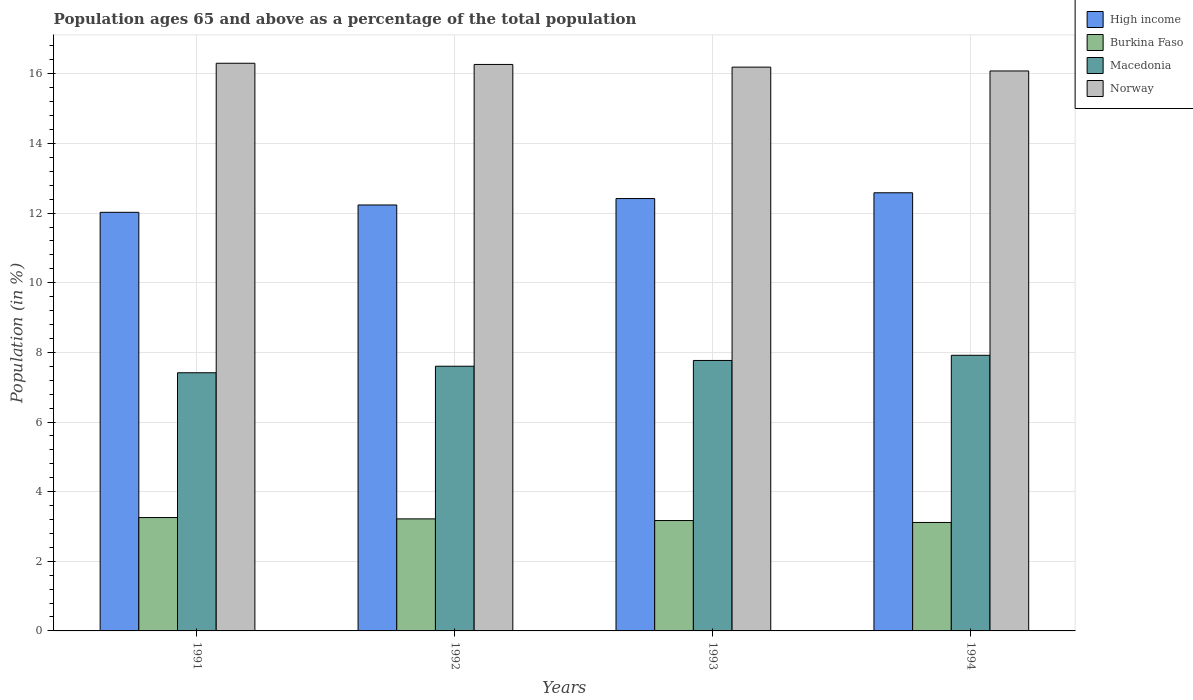How many different coloured bars are there?
Make the answer very short. 4. How many groups of bars are there?
Your answer should be compact. 4. Are the number of bars on each tick of the X-axis equal?
Make the answer very short. Yes. How many bars are there on the 4th tick from the right?
Offer a very short reply. 4. What is the label of the 4th group of bars from the left?
Keep it short and to the point. 1994. In how many cases, is the number of bars for a given year not equal to the number of legend labels?
Give a very brief answer. 0. What is the percentage of the population ages 65 and above in Burkina Faso in 1992?
Your answer should be compact. 3.22. Across all years, what is the maximum percentage of the population ages 65 and above in Burkina Faso?
Provide a succinct answer. 3.26. Across all years, what is the minimum percentage of the population ages 65 and above in Burkina Faso?
Provide a succinct answer. 3.11. In which year was the percentage of the population ages 65 and above in High income minimum?
Ensure brevity in your answer.  1991. What is the total percentage of the population ages 65 and above in Burkina Faso in the graph?
Your answer should be compact. 12.76. What is the difference between the percentage of the population ages 65 and above in Norway in 1992 and that in 1994?
Your answer should be compact. 0.19. What is the difference between the percentage of the population ages 65 and above in Macedonia in 1992 and the percentage of the population ages 65 and above in Norway in 1993?
Offer a terse response. -8.59. What is the average percentage of the population ages 65 and above in Burkina Faso per year?
Your response must be concise. 3.19. In the year 1992, what is the difference between the percentage of the population ages 65 and above in Norway and percentage of the population ages 65 and above in High income?
Keep it short and to the point. 4.04. What is the ratio of the percentage of the population ages 65 and above in Macedonia in 1991 to that in 1994?
Keep it short and to the point. 0.94. Is the difference between the percentage of the population ages 65 and above in Norway in 1993 and 1994 greater than the difference between the percentage of the population ages 65 and above in High income in 1993 and 1994?
Make the answer very short. Yes. What is the difference between the highest and the second highest percentage of the population ages 65 and above in High income?
Provide a succinct answer. 0.17. What is the difference between the highest and the lowest percentage of the population ages 65 and above in Macedonia?
Your response must be concise. 0.5. What does the 3rd bar from the left in 1993 represents?
Provide a short and direct response. Macedonia. What does the 1st bar from the right in 1992 represents?
Make the answer very short. Norway. Is it the case that in every year, the sum of the percentage of the population ages 65 and above in Burkina Faso and percentage of the population ages 65 and above in Macedonia is greater than the percentage of the population ages 65 and above in High income?
Offer a very short reply. No. Are all the bars in the graph horizontal?
Make the answer very short. No. How many years are there in the graph?
Keep it short and to the point. 4. Does the graph contain any zero values?
Provide a short and direct response. No. How many legend labels are there?
Make the answer very short. 4. What is the title of the graph?
Offer a terse response. Population ages 65 and above as a percentage of the total population. What is the label or title of the X-axis?
Your answer should be compact. Years. What is the label or title of the Y-axis?
Your answer should be compact. Population (in %). What is the Population (in %) of High income in 1991?
Offer a terse response. 12.02. What is the Population (in %) of Burkina Faso in 1991?
Your answer should be very brief. 3.26. What is the Population (in %) of Macedonia in 1991?
Provide a succinct answer. 7.41. What is the Population (in %) in Norway in 1991?
Offer a very short reply. 16.3. What is the Population (in %) in High income in 1992?
Your answer should be very brief. 12.23. What is the Population (in %) in Burkina Faso in 1992?
Provide a succinct answer. 3.22. What is the Population (in %) in Macedonia in 1992?
Your answer should be very brief. 7.6. What is the Population (in %) in Norway in 1992?
Make the answer very short. 16.27. What is the Population (in %) in High income in 1993?
Ensure brevity in your answer.  12.42. What is the Population (in %) in Burkina Faso in 1993?
Keep it short and to the point. 3.17. What is the Population (in %) of Macedonia in 1993?
Your answer should be very brief. 7.77. What is the Population (in %) in Norway in 1993?
Offer a very short reply. 16.19. What is the Population (in %) in High income in 1994?
Give a very brief answer. 12.58. What is the Population (in %) in Burkina Faso in 1994?
Ensure brevity in your answer.  3.11. What is the Population (in %) in Macedonia in 1994?
Your answer should be compact. 7.92. What is the Population (in %) of Norway in 1994?
Provide a succinct answer. 16.08. Across all years, what is the maximum Population (in %) in High income?
Ensure brevity in your answer.  12.58. Across all years, what is the maximum Population (in %) of Burkina Faso?
Keep it short and to the point. 3.26. Across all years, what is the maximum Population (in %) of Macedonia?
Your answer should be very brief. 7.92. Across all years, what is the maximum Population (in %) in Norway?
Your answer should be compact. 16.3. Across all years, what is the minimum Population (in %) in High income?
Provide a succinct answer. 12.02. Across all years, what is the minimum Population (in %) of Burkina Faso?
Your response must be concise. 3.11. Across all years, what is the minimum Population (in %) in Macedonia?
Offer a terse response. 7.41. Across all years, what is the minimum Population (in %) of Norway?
Offer a terse response. 16.08. What is the total Population (in %) of High income in the graph?
Offer a terse response. 49.26. What is the total Population (in %) of Burkina Faso in the graph?
Your answer should be compact. 12.76. What is the total Population (in %) of Macedonia in the graph?
Offer a terse response. 30.7. What is the total Population (in %) of Norway in the graph?
Your answer should be very brief. 64.85. What is the difference between the Population (in %) in High income in 1991 and that in 1992?
Give a very brief answer. -0.21. What is the difference between the Population (in %) of Burkina Faso in 1991 and that in 1992?
Make the answer very short. 0.04. What is the difference between the Population (in %) of Macedonia in 1991 and that in 1992?
Provide a succinct answer. -0.19. What is the difference between the Population (in %) in Norway in 1991 and that in 1992?
Provide a succinct answer. 0.03. What is the difference between the Population (in %) of High income in 1991 and that in 1993?
Provide a succinct answer. -0.4. What is the difference between the Population (in %) in Burkina Faso in 1991 and that in 1993?
Your answer should be very brief. 0.09. What is the difference between the Population (in %) in Macedonia in 1991 and that in 1993?
Give a very brief answer. -0.35. What is the difference between the Population (in %) in Norway in 1991 and that in 1993?
Offer a very short reply. 0.11. What is the difference between the Population (in %) of High income in 1991 and that in 1994?
Provide a short and direct response. -0.56. What is the difference between the Population (in %) of Burkina Faso in 1991 and that in 1994?
Ensure brevity in your answer.  0.14. What is the difference between the Population (in %) of Macedonia in 1991 and that in 1994?
Provide a succinct answer. -0.5. What is the difference between the Population (in %) of Norway in 1991 and that in 1994?
Your answer should be very brief. 0.22. What is the difference between the Population (in %) of High income in 1992 and that in 1993?
Offer a terse response. -0.18. What is the difference between the Population (in %) of Burkina Faso in 1992 and that in 1993?
Your answer should be very brief. 0.05. What is the difference between the Population (in %) in Macedonia in 1992 and that in 1993?
Offer a very short reply. -0.17. What is the difference between the Population (in %) of Norway in 1992 and that in 1993?
Your response must be concise. 0.08. What is the difference between the Population (in %) of High income in 1992 and that in 1994?
Your answer should be very brief. -0.35. What is the difference between the Population (in %) in Burkina Faso in 1992 and that in 1994?
Keep it short and to the point. 0.1. What is the difference between the Population (in %) in Macedonia in 1992 and that in 1994?
Make the answer very short. -0.31. What is the difference between the Population (in %) of Norway in 1992 and that in 1994?
Ensure brevity in your answer.  0.19. What is the difference between the Population (in %) of High income in 1993 and that in 1994?
Offer a very short reply. -0.17. What is the difference between the Population (in %) of Burkina Faso in 1993 and that in 1994?
Provide a succinct answer. 0.06. What is the difference between the Population (in %) in Macedonia in 1993 and that in 1994?
Offer a terse response. -0.15. What is the difference between the Population (in %) in Norway in 1993 and that in 1994?
Offer a terse response. 0.11. What is the difference between the Population (in %) in High income in 1991 and the Population (in %) in Burkina Faso in 1992?
Your response must be concise. 8.8. What is the difference between the Population (in %) in High income in 1991 and the Population (in %) in Macedonia in 1992?
Provide a succinct answer. 4.42. What is the difference between the Population (in %) in High income in 1991 and the Population (in %) in Norway in 1992?
Provide a short and direct response. -4.25. What is the difference between the Population (in %) in Burkina Faso in 1991 and the Population (in %) in Macedonia in 1992?
Your response must be concise. -4.35. What is the difference between the Population (in %) in Burkina Faso in 1991 and the Population (in %) in Norway in 1992?
Your response must be concise. -13.01. What is the difference between the Population (in %) of Macedonia in 1991 and the Population (in %) of Norway in 1992?
Ensure brevity in your answer.  -8.85. What is the difference between the Population (in %) in High income in 1991 and the Population (in %) in Burkina Faso in 1993?
Ensure brevity in your answer.  8.85. What is the difference between the Population (in %) of High income in 1991 and the Population (in %) of Macedonia in 1993?
Offer a terse response. 4.25. What is the difference between the Population (in %) in High income in 1991 and the Population (in %) in Norway in 1993?
Give a very brief answer. -4.17. What is the difference between the Population (in %) of Burkina Faso in 1991 and the Population (in %) of Macedonia in 1993?
Ensure brevity in your answer.  -4.51. What is the difference between the Population (in %) of Burkina Faso in 1991 and the Population (in %) of Norway in 1993?
Give a very brief answer. -12.94. What is the difference between the Population (in %) of Macedonia in 1991 and the Population (in %) of Norway in 1993?
Provide a short and direct response. -8.78. What is the difference between the Population (in %) of High income in 1991 and the Population (in %) of Burkina Faso in 1994?
Provide a short and direct response. 8.91. What is the difference between the Population (in %) of High income in 1991 and the Population (in %) of Macedonia in 1994?
Keep it short and to the point. 4.11. What is the difference between the Population (in %) of High income in 1991 and the Population (in %) of Norway in 1994?
Make the answer very short. -4.06. What is the difference between the Population (in %) of Burkina Faso in 1991 and the Population (in %) of Macedonia in 1994?
Keep it short and to the point. -4.66. What is the difference between the Population (in %) of Burkina Faso in 1991 and the Population (in %) of Norway in 1994?
Your answer should be compact. -12.83. What is the difference between the Population (in %) of Macedonia in 1991 and the Population (in %) of Norway in 1994?
Give a very brief answer. -8.67. What is the difference between the Population (in %) of High income in 1992 and the Population (in %) of Burkina Faso in 1993?
Your answer should be compact. 9.06. What is the difference between the Population (in %) of High income in 1992 and the Population (in %) of Macedonia in 1993?
Your response must be concise. 4.46. What is the difference between the Population (in %) in High income in 1992 and the Population (in %) in Norway in 1993?
Provide a succinct answer. -3.96. What is the difference between the Population (in %) of Burkina Faso in 1992 and the Population (in %) of Macedonia in 1993?
Provide a short and direct response. -4.55. What is the difference between the Population (in %) in Burkina Faso in 1992 and the Population (in %) in Norway in 1993?
Your answer should be compact. -12.97. What is the difference between the Population (in %) of Macedonia in 1992 and the Population (in %) of Norway in 1993?
Your response must be concise. -8.59. What is the difference between the Population (in %) in High income in 1992 and the Population (in %) in Burkina Faso in 1994?
Keep it short and to the point. 9.12. What is the difference between the Population (in %) of High income in 1992 and the Population (in %) of Macedonia in 1994?
Ensure brevity in your answer.  4.32. What is the difference between the Population (in %) in High income in 1992 and the Population (in %) in Norway in 1994?
Keep it short and to the point. -3.85. What is the difference between the Population (in %) in Burkina Faso in 1992 and the Population (in %) in Macedonia in 1994?
Keep it short and to the point. -4.7. What is the difference between the Population (in %) in Burkina Faso in 1992 and the Population (in %) in Norway in 1994?
Offer a very short reply. -12.86. What is the difference between the Population (in %) in Macedonia in 1992 and the Population (in %) in Norway in 1994?
Your response must be concise. -8.48. What is the difference between the Population (in %) of High income in 1993 and the Population (in %) of Burkina Faso in 1994?
Give a very brief answer. 9.3. What is the difference between the Population (in %) of High income in 1993 and the Population (in %) of Macedonia in 1994?
Offer a terse response. 4.5. What is the difference between the Population (in %) of High income in 1993 and the Population (in %) of Norway in 1994?
Your response must be concise. -3.66. What is the difference between the Population (in %) of Burkina Faso in 1993 and the Population (in %) of Macedonia in 1994?
Ensure brevity in your answer.  -4.75. What is the difference between the Population (in %) of Burkina Faso in 1993 and the Population (in %) of Norway in 1994?
Offer a terse response. -12.91. What is the difference between the Population (in %) in Macedonia in 1993 and the Population (in %) in Norway in 1994?
Keep it short and to the point. -8.31. What is the average Population (in %) in High income per year?
Make the answer very short. 12.31. What is the average Population (in %) in Burkina Faso per year?
Give a very brief answer. 3.19. What is the average Population (in %) in Macedonia per year?
Offer a terse response. 7.67. What is the average Population (in %) of Norway per year?
Give a very brief answer. 16.21. In the year 1991, what is the difference between the Population (in %) of High income and Population (in %) of Burkina Faso?
Offer a terse response. 8.77. In the year 1991, what is the difference between the Population (in %) in High income and Population (in %) in Macedonia?
Your answer should be compact. 4.61. In the year 1991, what is the difference between the Population (in %) of High income and Population (in %) of Norway?
Give a very brief answer. -4.28. In the year 1991, what is the difference between the Population (in %) of Burkina Faso and Population (in %) of Macedonia?
Offer a terse response. -4.16. In the year 1991, what is the difference between the Population (in %) in Burkina Faso and Population (in %) in Norway?
Ensure brevity in your answer.  -13.05. In the year 1991, what is the difference between the Population (in %) of Macedonia and Population (in %) of Norway?
Your answer should be very brief. -8.89. In the year 1992, what is the difference between the Population (in %) of High income and Population (in %) of Burkina Faso?
Your answer should be very brief. 9.01. In the year 1992, what is the difference between the Population (in %) in High income and Population (in %) in Macedonia?
Ensure brevity in your answer.  4.63. In the year 1992, what is the difference between the Population (in %) in High income and Population (in %) in Norway?
Give a very brief answer. -4.04. In the year 1992, what is the difference between the Population (in %) of Burkina Faso and Population (in %) of Macedonia?
Make the answer very short. -4.38. In the year 1992, what is the difference between the Population (in %) in Burkina Faso and Population (in %) in Norway?
Ensure brevity in your answer.  -13.05. In the year 1992, what is the difference between the Population (in %) of Macedonia and Population (in %) of Norway?
Provide a short and direct response. -8.67. In the year 1993, what is the difference between the Population (in %) of High income and Population (in %) of Burkina Faso?
Provide a succinct answer. 9.25. In the year 1993, what is the difference between the Population (in %) in High income and Population (in %) in Macedonia?
Make the answer very short. 4.65. In the year 1993, what is the difference between the Population (in %) of High income and Population (in %) of Norway?
Your answer should be compact. -3.77. In the year 1993, what is the difference between the Population (in %) in Burkina Faso and Population (in %) in Macedonia?
Make the answer very short. -4.6. In the year 1993, what is the difference between the Population (in %) in Burkina Faso and Population (in %) in Norway?
Offer a very short reply. -13.02. In the year 1993, what is the difference between the Population (in %) of Macedonia and Population (in %) of Norway?
Your answer should be compact. -8.42. In the year 1994, what is the difference between the Population (in %) in High income and Population (in %) in Burkina Faso?
Offer a very short reply. 9.47. In the year 1994, what is the difference between the Population (in %) of High income and Population (in %) of Macedonia?
Offer a terse response. 4.67. In the year 1994, what is the difference between the Population (in %) of High income and Population (in %) of Norway?
Your answer should be very brief. -3.5. In the year 1994, what is the difference between the Population (in %) in Burkina Faso and Population (in %) in Macedonia?
Provide a short and direct response. -4.8. In the year 1994, what is the difference between the Population (in %) of Burkina Faso and Population (in %) of Norway?
Give a very brief answer. -12.97. In the year 1994, what is the difference between the Population (in %) in Macedonia and Population (in %) in Norway?
Offer a terse response. -8.17. What is the ratio of the Population (in %) in High income in 1991 to that in 1992?
Ensure brevity in your answer.  0.98. What is the ratio of the Population (in %) in Burkina Faso in 1991 to that in 1992?
Your answer should be compact. 1.01. What is the ratio of the Population (in %) in Macedonia in 1991 to that in 1992?
Offer a terse response. 0.98. What is the ratio of the Population (in %) of Norway in 1991 to that in 1992?
Your answer should be very brief. 1. What is the ratio of the Population (in %) of High income in 1991 to that in 1993?
Provide a succinct answer. 0.97. What is the ratio of the Population (in %) of Macedonia in 1991 to that in 1993?
Provide a short and direct response. 0.95. What is the ratio of the Population (in %) in Norway in 1991 to that in 1993?
Ensure brevity in your answer.  1.01. What is the ratio of the Population (in %) of High income in 1991 to that in 1994?
Ensure brevity in your answer.  0.96. What is the ratio of the Population (in %) of Burkina Faso in 1991 to that in 1994?
Provide a short and direct response. 1.05. What is the ratio of the Population (in %) of Macedonia in 1991 to that in 1994?
Ensure brevity in your answer.  0.94. What is the ratio of the Population (in %) of Norway in 1991 to that in 1994?
Your response must be concise. 1.01. What is the ratio of the Population (in %) of High income in 1992 to that in 1993?
Offer a very short reply. 0.99. What is the ratio of the Population (in %) of Macedonia in 1992 to that in 1993?
Give a very brief answer. 0.98. What is the ratio of the Population (in %) of High income in 1992 to that in 1994?
Ensure brevity in your answer.  0.97. What is the ratio of the Population (in %) of Burkina Faso in 1992 to that in 1994?
Your answer should be compact. 1.03. What is the ratio of the Population (in %) in Macedonia in 1992 to that in 1994?
Offer a very short reply. 0.96. What is the ratio of the Population (in %) in Norway in 1992 to that in 1994?
Your response must be concise. 1.01. What is the ratio of the Population (in %) of High income in 1993 to that in 1994?
Keep it short and to the point. 0.99. What is the ratio of the Population (in %) of Burkina Faso in 1993 to that in 1994?
Make the answer very short. 1.02. What is the ratio of the Population (in %) of Macedonia in 1993 to that in 1994?
Your response must be concise. 0.98. What is the ratio of the Population (in %) in Norway in 1993 to that in 1994?
Provide a succinct answer. 1.01. What is the difference between the highest and the second highest Population (in %) of High income?
Make the answer very short. 0.17. What is the difference between the highest and the second highest Population (in %) in Burkina Faso?
Offer a very short reply. 0.04. What is the difference between the highest and the second highest Population (in %) of Macedonia?
Provide a succinct answer. 0.15. What is the difference between the highest and the second highest Population (in %) in Norway?
Your answer should be compact. 0.03. What is the difference between the highest and the lowest Population (in %) in High income?
Make the answer very short. 0.56. What is the difference between the highest and the lowest Population (in %) in Burkina Faso?
Ensure brevity in your answer.  0.14. What is the difference between the highest and the lowest Population (in %) in Macedonia?
Give a very brief answer. 0.5. What is the difference between the highest and the lowest Population (in %) in Norway?
Make the answer very short. 0.22. 